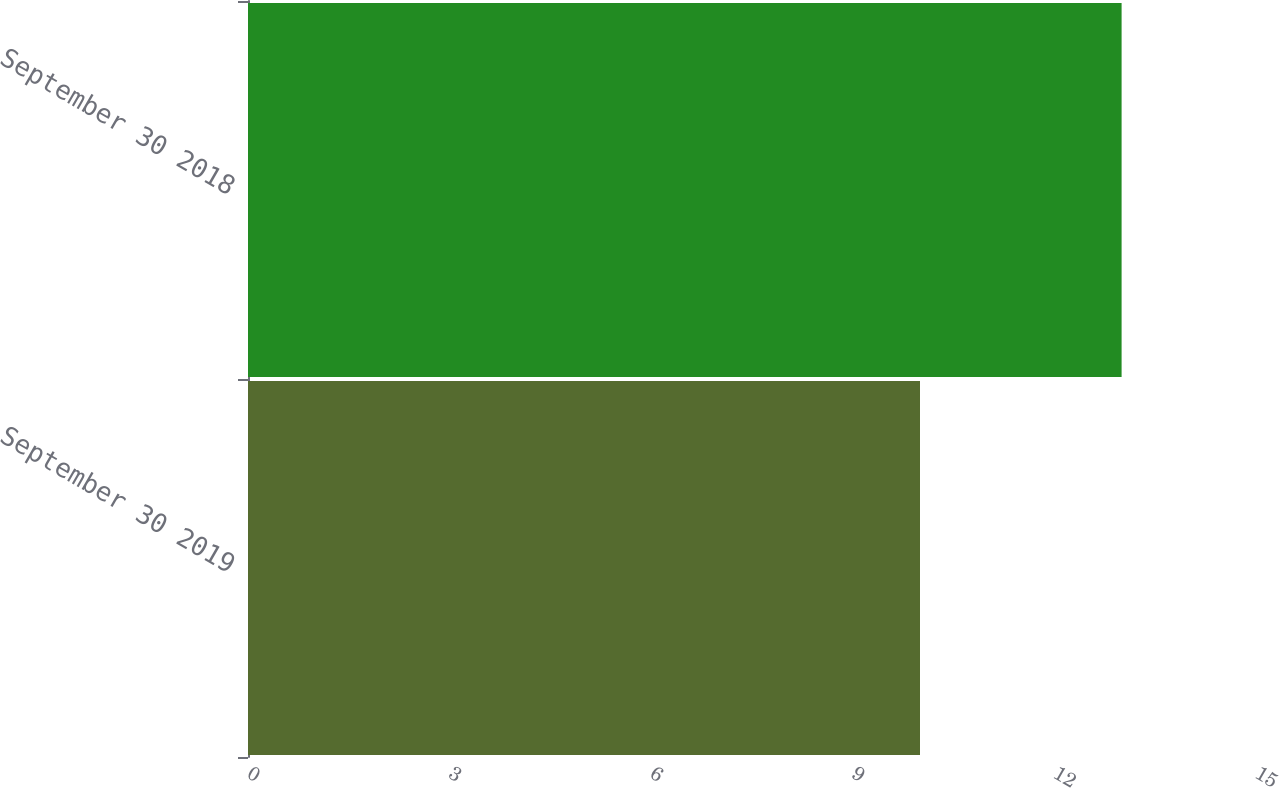Convert chart to OTSL. <chart><loc_0><loc_0><loc_500><loc_500><bar_chart><fcel>September 30 2019<fcel>September 30 2018<nl><fcel>10<fcel>13<nl></chart> 